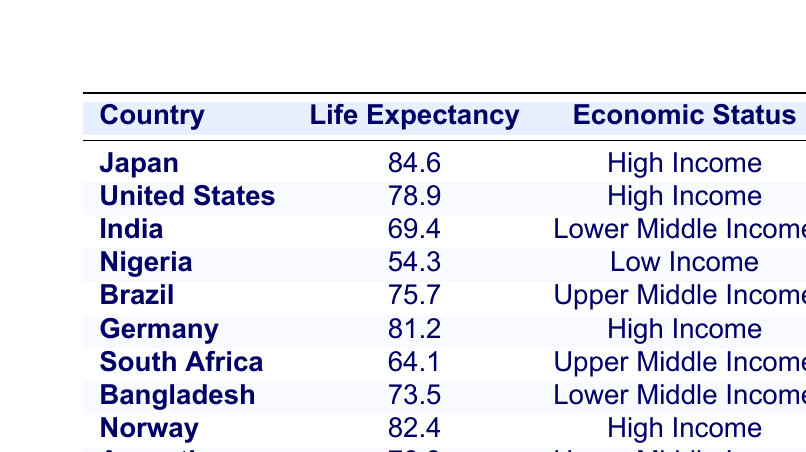What is the life expectancy of Japan? From the table, Japan's life expectancy is listed directly in the row corresponding to Japan, which is 84.6 years.
Answer: 84.6 Which country has the lowest life expectancy? In the table, Nigeria has the lowest life expectancy, which is 54.3 years, as indicated by comparing all the values in the Life Expectancy column.
Answer: Nigeria What is the average life expectancy of countries classified as High Income? The High Income countries in the table are Japan (84.6), United States (78.9), Germany (81.2), and Norway (82.4). To find the average, sum these values: 84.6 + 78.9 + 81.2 + 82.4 = 327.1. Divide by the number of countries: 327.1 / 4 = 81.775.
Answer: 81.775 Do any Upper Middle Income countries have a life expectancy below 70 years? From the table, South Africa (64.1) is the only Upper Middle Income country with a life expectancy below 70 years. Upon reviewing the data for upper middle income entries, it confirms that South Africa is the only such case.
Answer: Yes How does India's life expectancy compare to the average life expectancy of Lower Middle Income countries? India has a life expectancy of 69.4. The Lower Middle Income countries are India (69.4) and Bangladesh (73.5). Their average is calculated by summing their life expectancies: 69.4 + 73.5 = 142.9, then dividing by 2 gives 142.9 / 2 = 71.45. Since 69.4 is less than 71.45, India has a lower life expectancy than the average of Lower Middle Income countries.
Answer: India's is lower What is the total life expectancy of all countries in the table? To find the total, add up all the life expectancies: 84.6 + 78.9 + 69.4 + 54.3 + 75.7 + 81.2 + 64.1 + 73.5 + 82.4 + 76.3 =  770.0.
Answer: 770.0 Is the life expectancy of Brazil greater than that of the United States? Brazil has a life expectancy of 75.7 and the United States has 78.9. Comparing these values shows that 75.7 is less than 78.9, confirming that Brazil's life expectancy is not greater.
Answer: No Which economy status holds the country with the highest life expectancy? Japan has the highest life expectancy at 84.6 years, and it is classified as a High Income country. This is confirmed by examining the Life Expectancy column and identifying Japan as the country with the maximum value.
Answer: High Income 